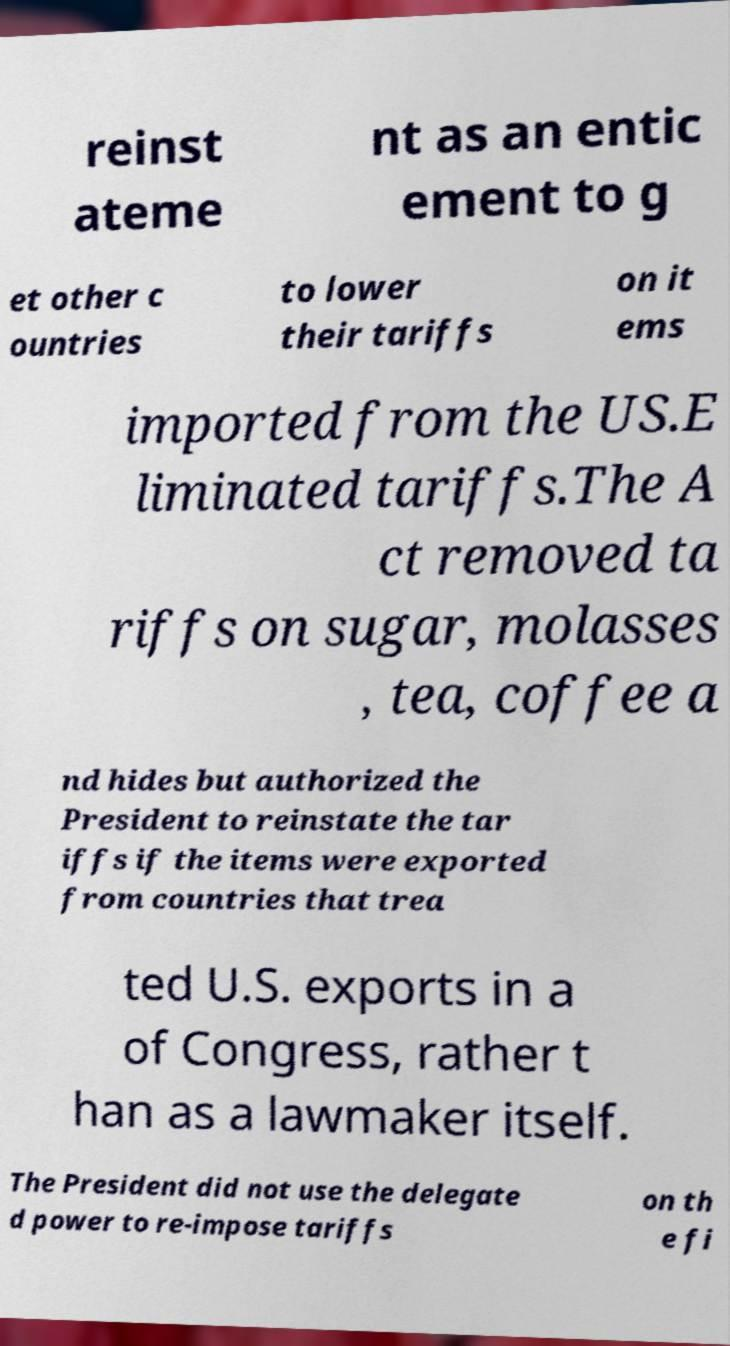There's text embedded in this image that I need extracted. Can you transcribe it verbatim? reinst ateme nt as an entic ement to g et other c ountries to lower their tariffs on it ems imported from the US.E liminated tariffs.The A ct removed ta riffs on sugar, molasses , tea, coffee a nd hides but authorized the President to reinstate the tar iffs if the items were exported from countries that trea ted U.S. exports in a of Congress, rather t han as a lawmaker itself. The President did not use the delegate d power to re-impose tariffs on th e fi 